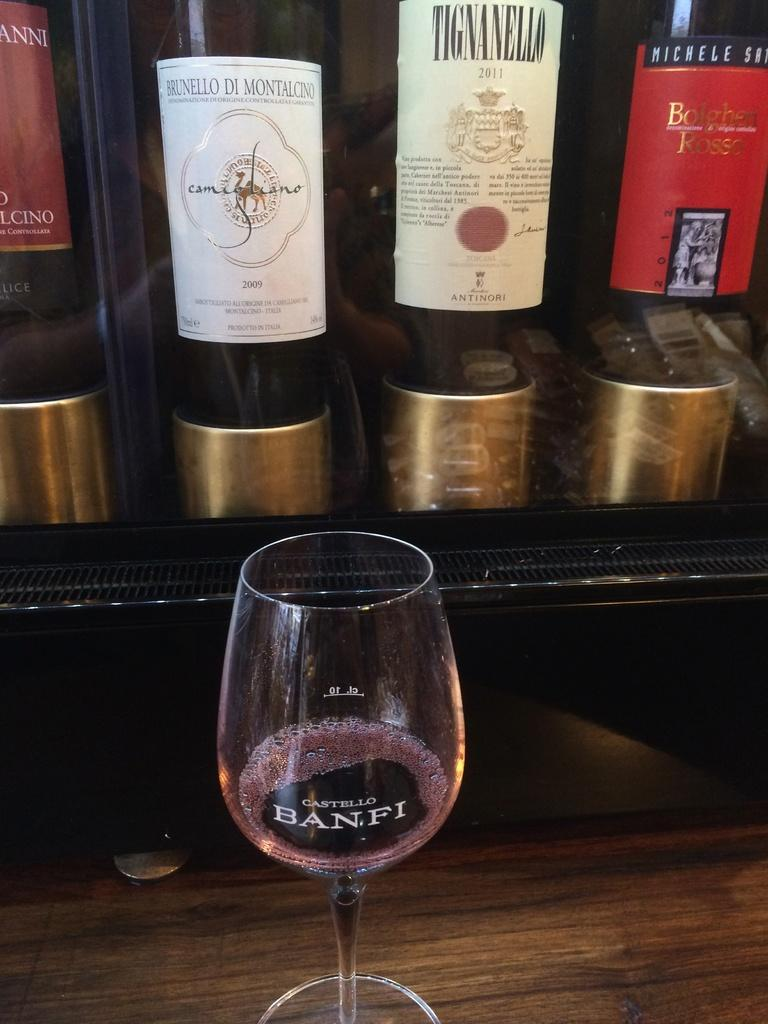<image>
Present a compact description of the photo's key features. A Castello Banfi glass with several bottles behind it. 